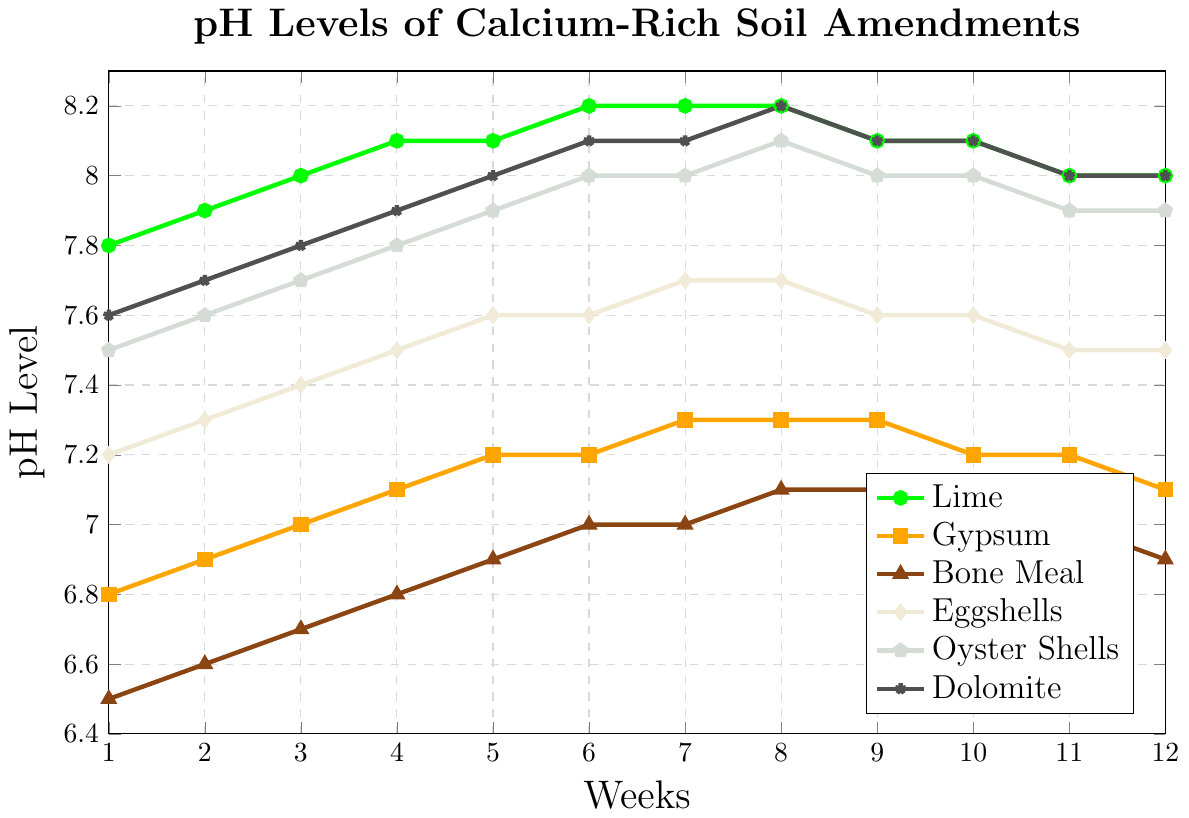Which soil amendment has the highest initial pH level in Week 1? From the graph, look at the starting pH levels of each amendment in Week 1. Lime starts at 7.8, Gypsum at 6.8, Bone Meal at 6.5, Eggshells at 7.2, Oyster Shells at 7.5, and Dolomite at 7.6. Lime has the highest initial pH level.
Answer: Lime How does the pH level of Gypsum change from Week 1 to Week 12? Look at the pH levels of Gypsum at Week 1 (6.8) and Week 12 (7.1). The pH level increases by (7.1 - 6.8) = 0.3 over the 12 weeks.
Answer: Increases by 0.3 Which amendment shows the least change in pH level over 12 weeks? Evaluate the change in pH levels from Week 1 to Week 12 for each amendment. Lime (7.8 to 8.0 = 0.2), Gypsum (6.8 to 7.1 = 0.3), Bone Meal (6.5 to 6.9 = 0.4), Eggshells (7.2 to 7.5 = 0.3), Oyster Shells (7.5 to 7.9 = 0.4), Dolomite (7.6 to 8.0 = 0.4). Lime shows the least change.
Answer: Lime What is the average pH level of Eggshells from Week 1 to Week 12? Find the sum of Eggshell pH levels and divide by the number of weeks: (7.2 + 7.3 + 7.4 + 7.5 + 7.6 + 7.6 + 7.7 + 7.7 + 7.6 + 7.6 + 7.5 + 7.5) / 12 = 90.2 / 12 = 7.52.
Answer: 7.52 Compare the pH trend of Dolomite and Lime. Are they similar? Observe both lines in the graph. Dolomite and Lime both start around 7.8, increase gradually to around 8.2, and then slightly decrease back to 8.0 by Week 12. Their trends are similar, showing a gradual increase and then stabilizing.
Answer: Yes Which amendment has the highest pH level in Week 6? Check the pH levels of all amendments in Week 6: Lime (8.2), Gypsum (7.2), Bone Meal (7.0), Eggshells (7.6), Oyster Shells (8.0), Dolomite (8.1). Lime has the highest pH level in Week 6.
Answer: Lime Is there any week where the pH levels of Gypsum and Bone Meal are equal? Cross-check the pH levels of Gypsum and Bone Meal across all weeks to see if they match. At no week do the values exactly match.
Answer: No Which two amendments have the closest pH levels in Week 11? Compare the pH levels of all amendments in Week 11: Lime (8.0), Gypsum (7.2), Bone Meal (7.0), Eggshells (7.5), Oyster Shells (7.9), Dolomite (8.0). Lime and Dolomite both are closest at 8.0.
Answer: Lime and Dolomite How much does the pH level of Bone Meal increase from Week 1 to Week 5? Subtract the pH level of Bone Meal at Week 1 (6.5) from the level at Week 5 (6.9), which is 6.9 - 6.5 = 0.4.
Answer: 0.4 What's the most significant drop in pH level observed for any amendment in any week? Evaluate the weekly pH changes for each amendment and look for the maximum drop. One such drop is Gypsum from Week 11 (7.2) to Week 12 (7.1), which is a 0.1 drop. It appears no greater drop happens for any other amendment in any week.
Answer: 0.1 